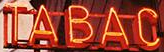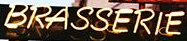Read the text content from these images in order, separated by a semicolon. TABAC; BRASSERIE 